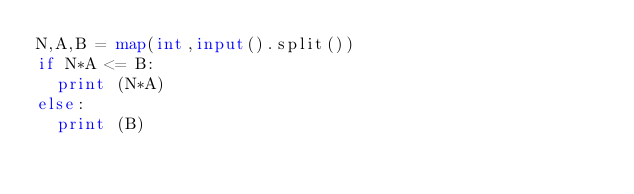<code> <loc_0><loc_0><loc_500><loc_500><_Python_>N,A,B = map(int,input().split())
if N*A <= B:
  print (N*A)
else:
  print (B)</code> 